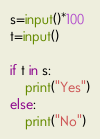<code> <loc_0><loc_0><loc_500><loc_500><_Python_>s=input()*100
t=input()

if t in s:
    print("Yes")
else:
    print("No")
</code> 